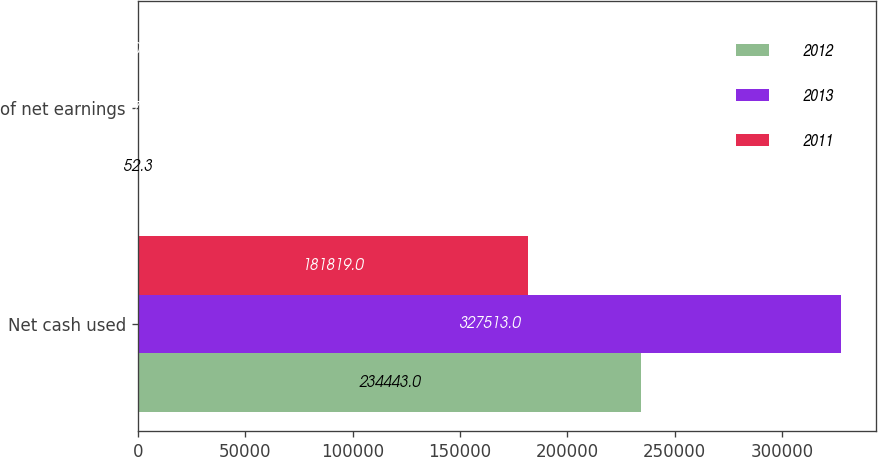Convert chart. <chart><loc_0><loc_0><loc_500><loc_500><stacked_bar_chart><ecel><fcel>Net cash used<fcel>of net earnings<nl><fcel>2012<fcel>234443<fcel>52.3<nl><fcel>2013<fcel>327513<fcel>77.9<nl><fcel>2011<fcel>181819<fcel>50.8<nl></chart> 